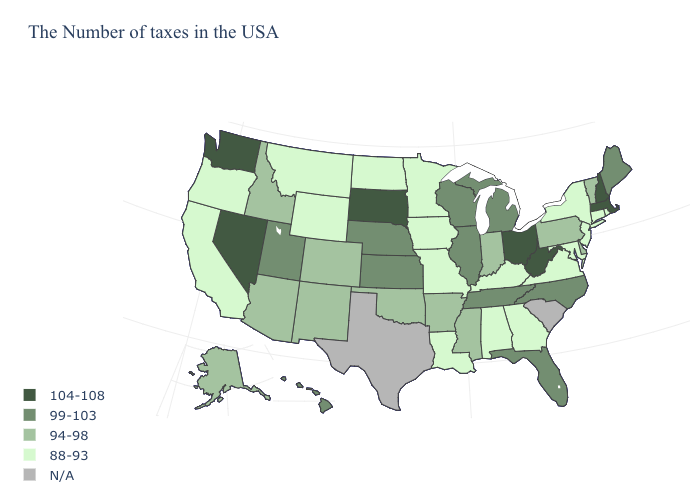What is the value of Ohio?
Write a very short answer. 104-108. Is the legend a continuous bar?
Write a very short answer. No. Which states have the lowest value in the Northeast?
Give a very brief answer. Rhode Island, Connecticut, New York, New Jersey. Does Nevada have the highest value in the West?
Quick response, please. Yes. What is the lowest value in the West?
Short answer required. 88-93. Among the states that border South Carolina , does North Carolina have the highest value?
Be succinct. Yes. Name the states that have a value in the range 99-103?
Be succinct. Maine, North Carolina, Florida, Michigan, Tennessee, Wisconsin, Illinois, Kansas, Nebraska, Utah, Hawaii. Does Oregon have the highest value in the West?
Write a very short answer. No. Name the states that have a value in the range 104-108?
Give a very brief answer. Massachusetts, New Hampshire, West Virginia, Ohio, South Dakota, Nevada, Washington. What is the value of Arkansas?
Short answer required. 94-98. Which states have the lowest value in the USA?
Be succinct. Rhode Island, Connecticut, New York, New Jersey, Maryland, Virginia, Georgia, Kentucky, Alabama, Louisiana, Missouri, Minnesota, Iowa, North Dakota, Wyoming, Montana, California, Oregon. Name the states that have a value in the range 104-108?
Be succinct. Massachusetts, New Hampshire, West Virginia, Ohio, South Dakota, Nevada, Washington. What is the highest value in the USA?
Short answer required. 104-108. What is the value of Maine?
Quick response, please. 99-103. Name the states that have a value in the range 104-108?
Quick response, please. Massachusetts, New Hampshire, West Virginia, Ohio, South Dakota, Nevada, Washington. 